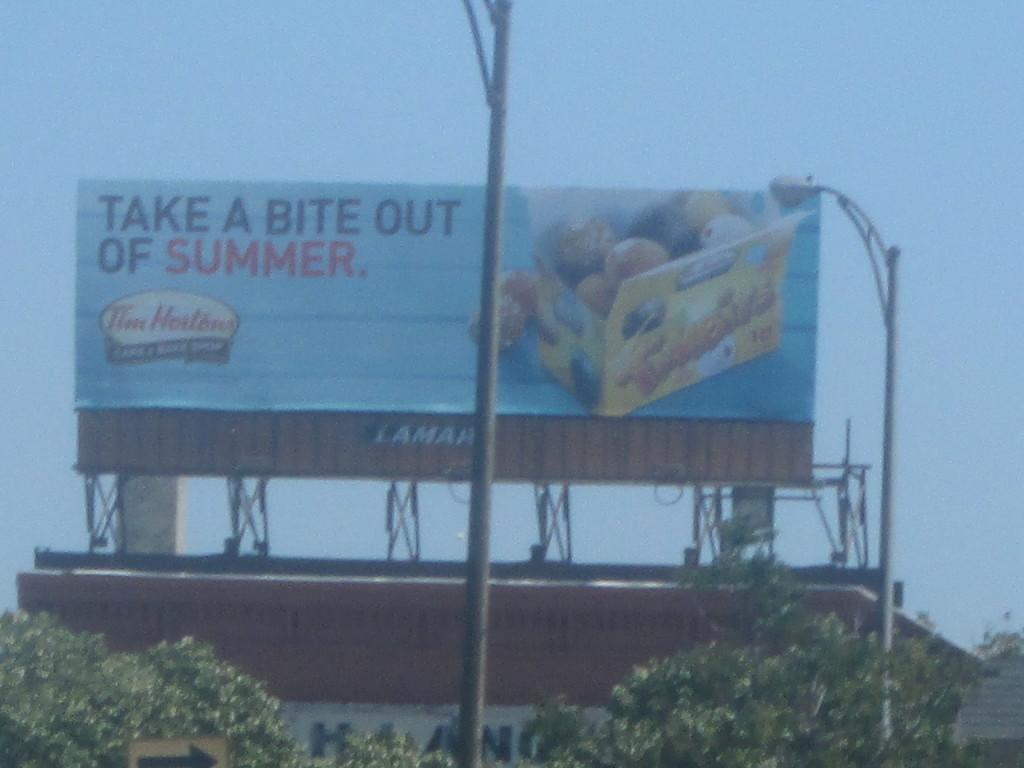What company is this ad from?
Ensure brevity in your answer.  Tim hortons. What season is shown on this billboard?
Keep it short and to the point. Summer. 